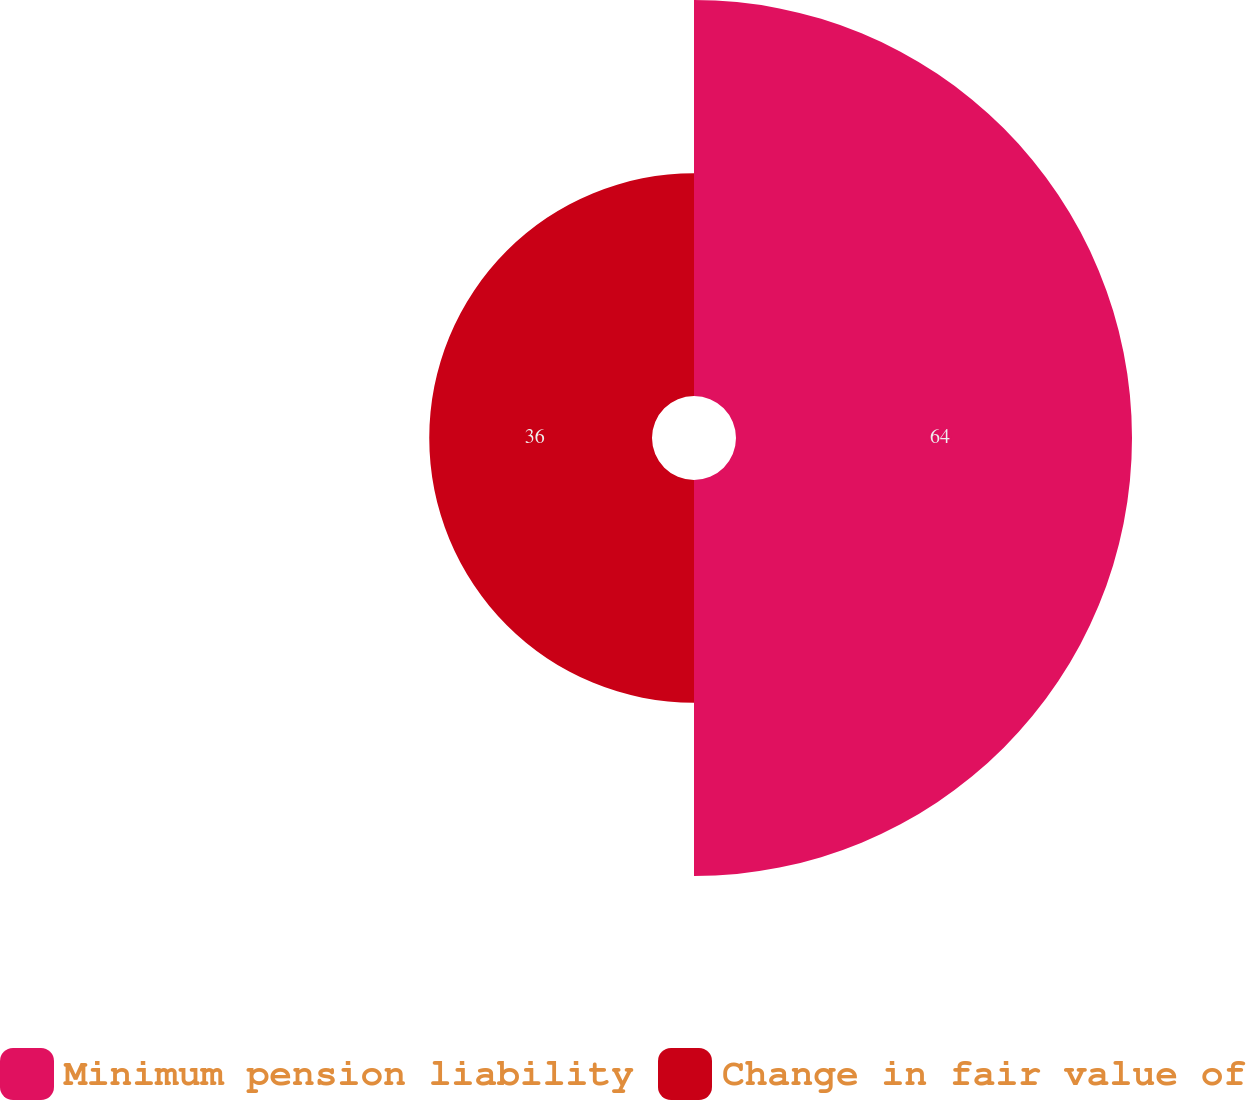Convert chart. <chart><loc_0><loc_0><loc_500><loc_500><pie_chart><fcel>Minimum pension liability<fcel>Change in fair value of<nl><fcel>64.0%<fcel>36.0%<nl></chart> 